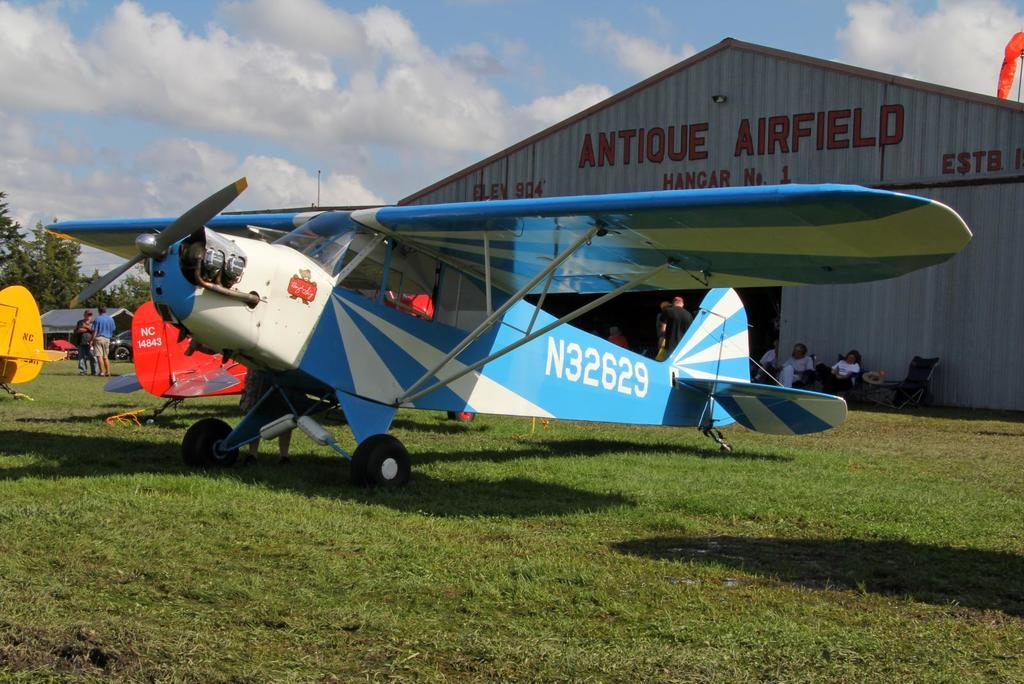What type of vehicles are on the ground in the image? There are aircrafts on the ground in the image. What is the ground covered with? The ground is covered with grass. What type of vegetation can be seen in the image? There are trees in the image. What type of structure is present in the image? There is a shed in the image. What is visible in the sky in the image? The sky is visible in the image, and clouds are present. How many straws are being used by the sheep in the image? There are no sheep or straws present in the image. 